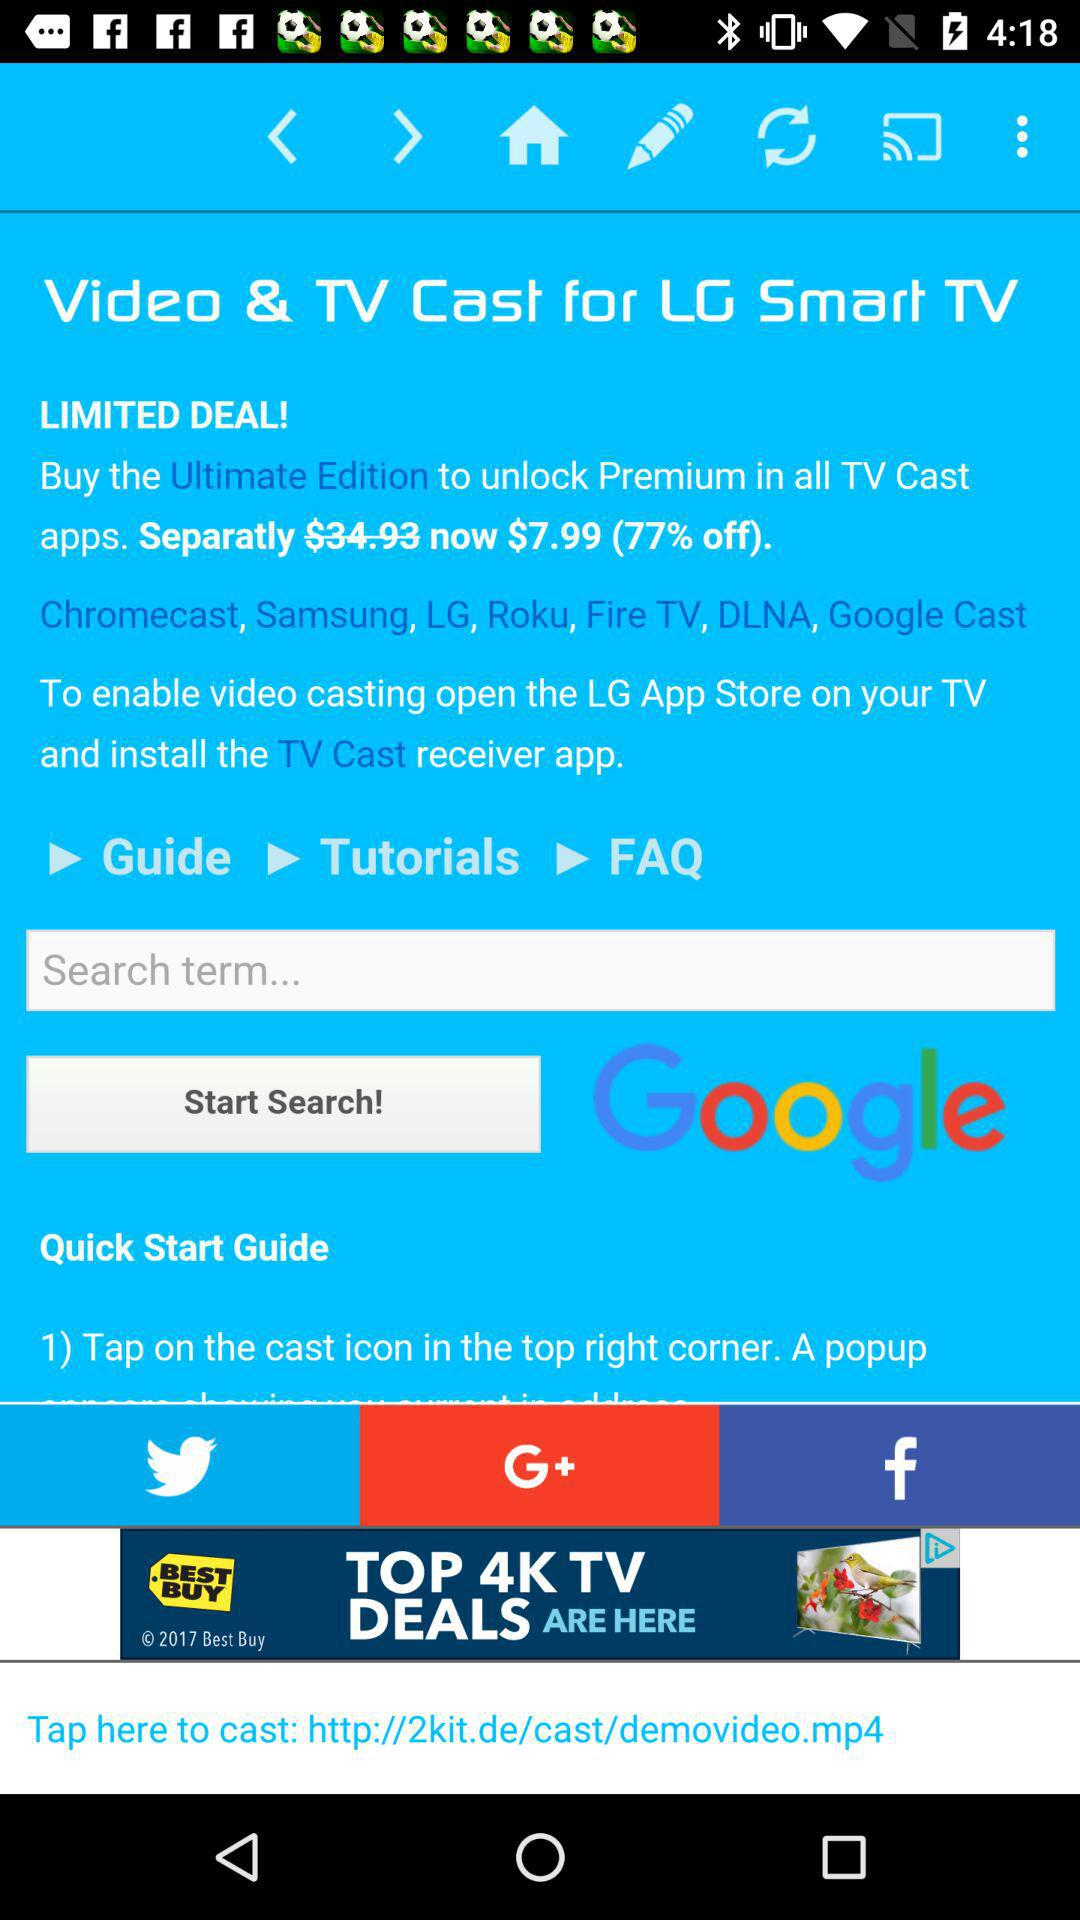What is the "Separatly" price? The price is $7.99. 